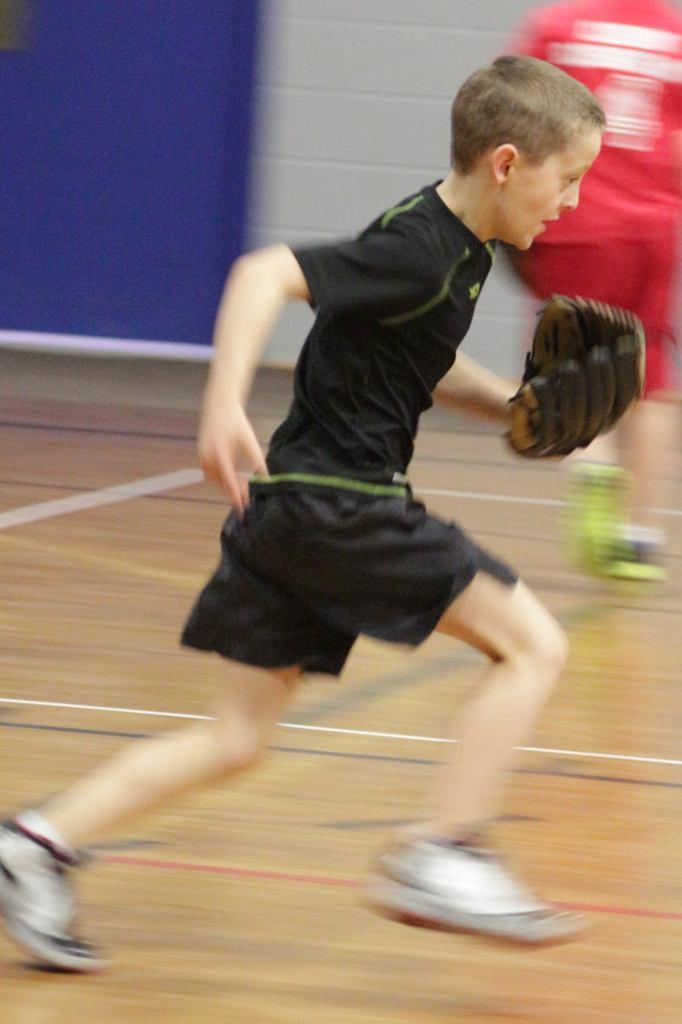Who is the main subject in the image? There is a boy in the image. What is the boy doing in the image? The boy is running on the floor. Can you describe the background of the image? There is a person and a wall in the background of the image. What type of cheese is the boy holding while running in the image? There is no cheese present in the image; the boy is running without holding anything. 